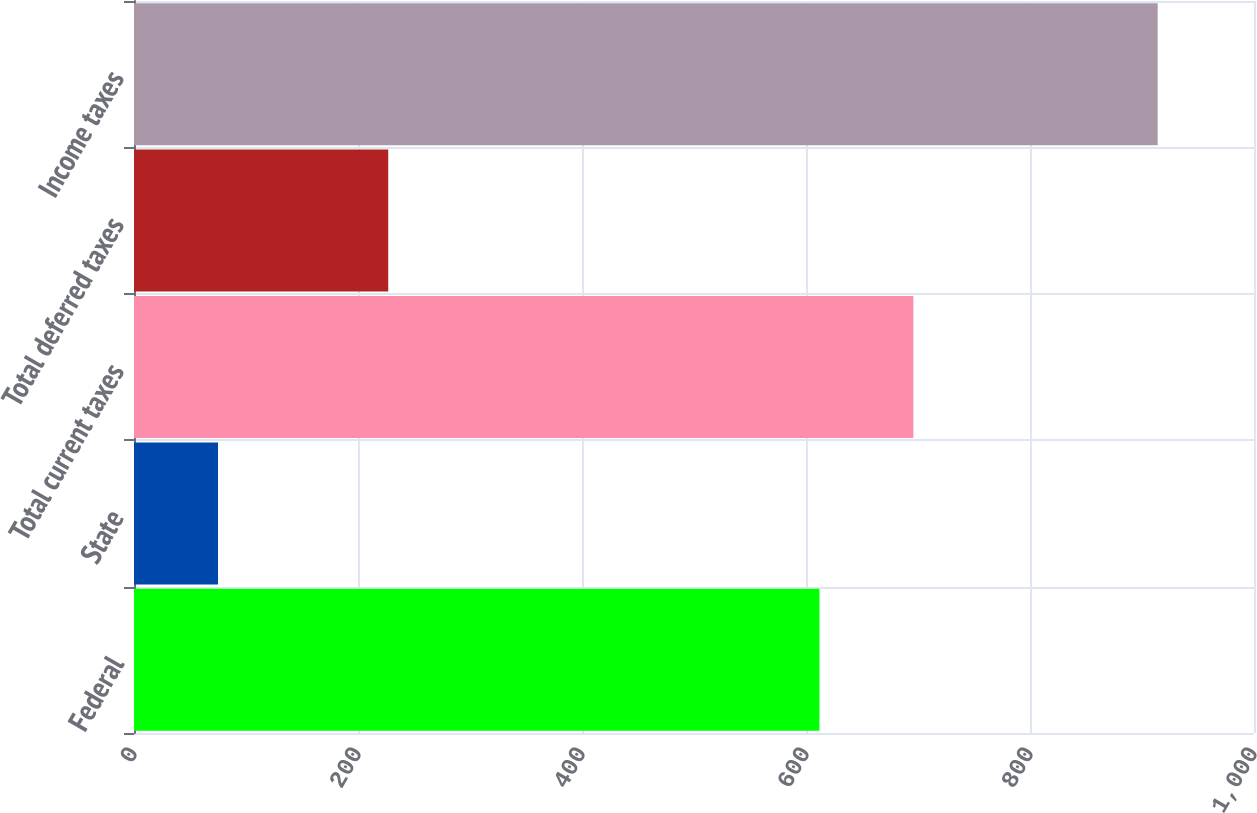Convert chart. <chart><loc_0><loc_0><loc_500><loc_500><bar_chart><fcel>Federal<fcel>State<fcel>Total current taxes<fcel>Total deferred taxes<fcel>Income taxes<nl><fcel>612<fcel>75<fcel>695.9<fcel>227<fcel>914<nl></chart> 